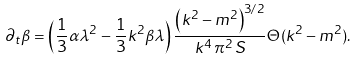Convert formula to latex. <formula><loc_0><loc_0><loc_500><loc_500>\partial _ { t } \beta = \left ( \frac { 1 } { 3 } \alpha \lambda ^ { 2 } - \frac { 1 } { 3 } k ^ { 2 } \beta \lambda \right ) \frac { \left ( k ^ { 2 } - m ^ { 2 } \right ) ^ { 3 / 2 } } { k ^ { 4 } \, \pi ^ { 2 } \, S } \Theta ( k ^ { 2 } - m ^ { 2 } ) .</formula> 